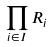Convert formula to latex. <formula><loc_0><loc_0><loc_500><loc_500>\prod _ { i \in I } R _ { i }</formula> 